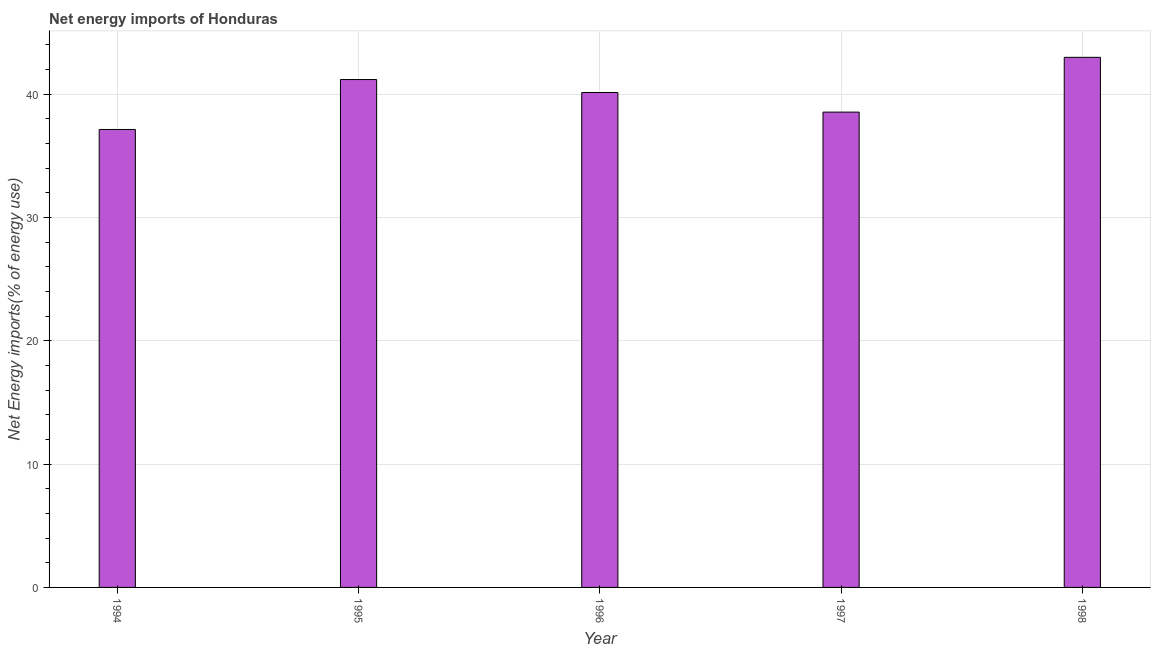What is the title of the graph?
Make the answer very short. Net energy imports of Honduras. What is the label or title of the Y-axis?
Give a very brief answer. Net Energy imports(% of energy use). What is the energy imports in 1994?
Your answer should be compact. 37.13. Across all years, what is the maximum energy imports?
Your answer should be compact. 42.98. Across all years, what is the minimum energy imports?
Your answer should be very brief. 37.13. What is the sum of the energy imports?
Offer a terse response. 199.97. What is the difference between the energy imports in 1996 and 1997?
Offer a terse response. 1.59. What is the average energy imports per year?
Offer a terse response. 39.99. What is the median energy imports?
Ensure brevity in your answer.  40.13. In how many years, is the energy imports greater than 28 %?
Ensure brevity in your answer.  5. What is the ratio of the energy imports in 1996 to that in 1997?
Give a very brief answer. 1.04. Is the difference between the energy imports in 1995 and 1998 greater than the difference between any two years?
Offer a terse response. No. What is the difference between the highest and the second highest energy imports?
Provide a short and direct response. 1.8. What is the difference between the highest and the lowest energy imports?
Keep it short and to the point. 5.85. In how many years, is the energy imports greater than the average energy imports taken over all years?
Provide a short and direct response. 3. What is the difference between two consecutive major ticks on the Y-axis?
Ensure brevity in your answer.  10. What is the Net Energy imports(% of energy use) in 1994?
Offer a very short reply. 37.13. What is the Net Energy imports(% of energy use) in 1995?
Your answer should be compact. 41.18. What is the Net Energy imports(% of energy use) in 1996?
Offer a very short reply. 40.13. What is the Net Energy imports(% of energy use) of 1997?
Give a very brief answer. 38.54. What is the Net Energy imports(% of energy use) in 1998?
Ensure brevity in your answer.  42.98. What is the difference between the Net Energy imports(% of energy use) in 1994 and 1995?
Keep it short and to the point. -4.05. What is the difference between the Net Energy imports(% of energy use) in 1994 and 1996?
Provide a short and direct response. -3. What is the difference between the Net Energy imports(% of energy use) in 1994 and 1997?
Your answer should be compact. -1.41. What is the difference between the Net Energy imports(% of energy use) in 1994 and 1998?
Make the answer very short. -5.85. What is the difference between the Net Energy imports(% of energy use) in 1995 and 1996?
Offer a terse response. 1.05. What is the difference between the Net Energy imports(% of energy use) in 1995 and 1997?
Your response must be concise. 2.64. What is the difference between the Net Energy imports(% of energy use) in 1995 and 1998?
Offer a very short reply. -1.8. What is the difference between the Net Energy imports(% of energy use) in 1996 and 1997?
Provide a succinct answer. 1.59. What is the difference between the Net Energy imports(% of energy use) in 1996 and 1998?
Provide a succinct answer. -2.85. What is the difference between the Net Energy imports(% of energy use) in 1997 and 1998?
Offer a very short reply. -4.44. What is the ratio of the Net Energy imports(% of energy use) in 1994 to that in 1995?
Your response must be concise. 0.9. What is the ratio of the Net Energy imports(% of energy use) in 1994 to that in 1996?
Provide a succinct answer. 0.93. What is the ratio of the Net Energy imports(% of energy use) in 1994 to that in 1998?
Provide a succinct answer. 0.86. What is the ratio of the Net Energy imports(% of energy use) in 1995 to that in 1997?
Your response must be concise. 1.07. What is the ratio of the Net Energy imports(% of energy use) in 1995 to that in 1998?
Provide a succinct answer. 0.96. What is the ratio of the Net Energy imports(% of energy use) in 1996 to that in 1997?
Your response must be concise. 1.04. What is the ratio of the Net Energy imports(% of energy use) in 1996 to that in 1998?
Your answer should be very brief. 0.93. What is the ratio of the Net Energy imports(% of energy use) in 1997 to that in 1998?
Your response must be concise. 0.9. 